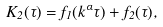<formula> <loc_0><loc_0><loc_500><loc_500>K _ { 2 } ( \tau ) = f _ { 1 } ( k ^ { \alpha } \tau ) + f _ { 2 } ( \tau ) ,</formula> 